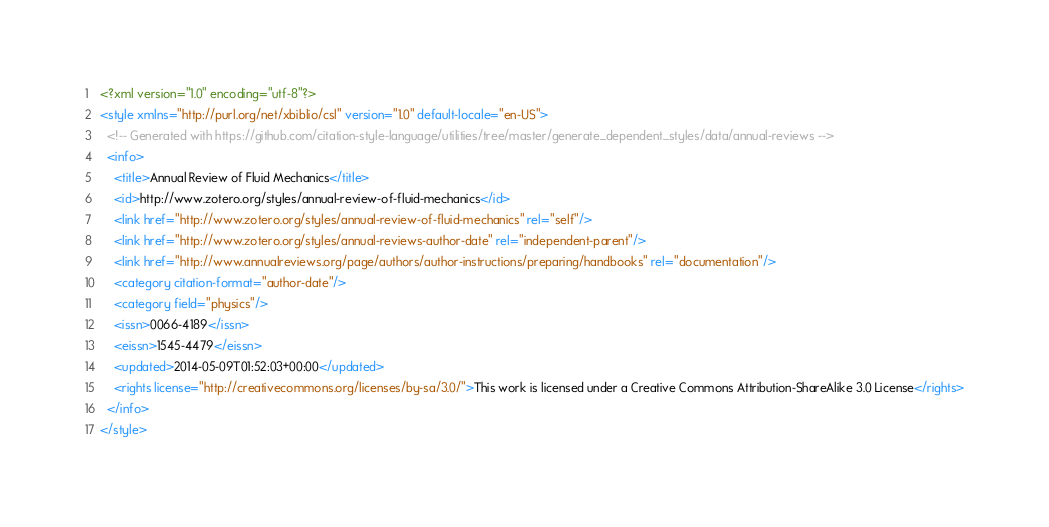<code> <loc_0><loc_0><loc_500><loc_500><_XML_><?xml version="1.0" encoding="utf-8"?>
<style xmlns="http://purl.org/net/xbiblio/csl" version="1.0" default-locale="en-US">
  <!-- Generated with https://github.com/citation-style-language/utilities/tree/master/generate_dependent_styles/data/annual-reviews -->
  <info>
    <title>Annual Review of Fluid Mechanics</title>
    <id>http://www.zotero.org/styles/annual-review-of-fluid-mechanics</id>
    <link href="http://www.zotero.org/styles/annual-review-of-fluid-mechanics" rel="self"/>
    <link href="http://www.zotero.org/styles/annual-reviews-author-date" rel="independent-parent"/>
    <link href="http://www.annualreviews.org/page/authors/author-instructions/preparing/handbooks" rel="documentation"/>
    <category citation-format="author-date"/>
    <category field="physics"/>
    <issn>0066-4189</issn>
    <eissn>1545-4479</eissn>
    <updated>2014-05-09T01:52:03+00:00</updated>
    <rights license="http://creativecommons.org/licenses/by-sa/3.0/">This work is licensed under a Creative Commons Attribution-ShareAlike 3.0 License</rights>
  </info>
</style>
</code> 